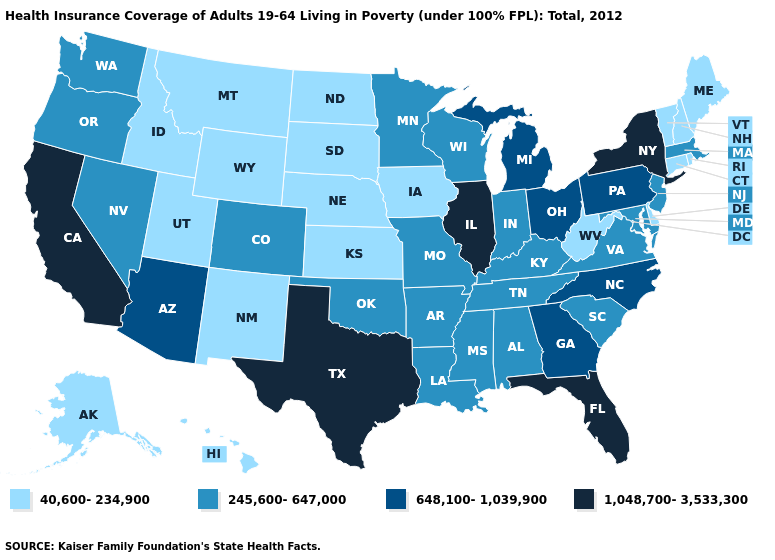Among the states that border Idaho , which have the lowest value?
Short answer required. Montana, Utah, Wyoming. Name the states that have a value in the range 40,600-234,900?
Short answer required. Alaska, Connecticut, Delaware, Hawaii, Idaho, Iowa, Kansas, Maine, Montana, Nebraska, New Hampshire, New Mexico, North Dakota, Rhode Island, South Dakota, Utah, Vermont, West Virginia, Wyoming. Which states have the highest value in the USA?
Quick response, please. California, Florida, Illinois, New York, Texas. What is the value of Arkansas?
Concise answer only. 245,600-647,000. Does Georgia have a higher value than California?
Be succinct. No. What is the value of New Hampshire?
Be succinct. 40,600-234,900. Which states have the highest value in the USA?
Quick response, please. California, Florida, Illinois, New York, Texas. Does the map have missing data?
Give a very brief answer. No. Name the states that have a value in the range 40,600-234,900?
Be succinct. Alaska, Connecticut, Delaware, Hawaii, Idaho, Iowa, Kansas, Maine, Montana, Nebraska, New Hampshire, New Mexico, North Dakota, Rhode Island, South Dakota, Utah, Vermont, West Virginia, Wyoming. Does New York have the highest value in the USA?
Answer briefly. Yes. What is the value of Arizona?
Write a very short answer. 648,100-1,039,900. Does Michigan have the same value as Arizona?
Give a very brief answer. Yes. Does Massachusetts have a higher value than Wisconsin?
Short answer required. No. Among the states that border South Dakota , which have the highest value?
Quick response, please. Minnesota. 